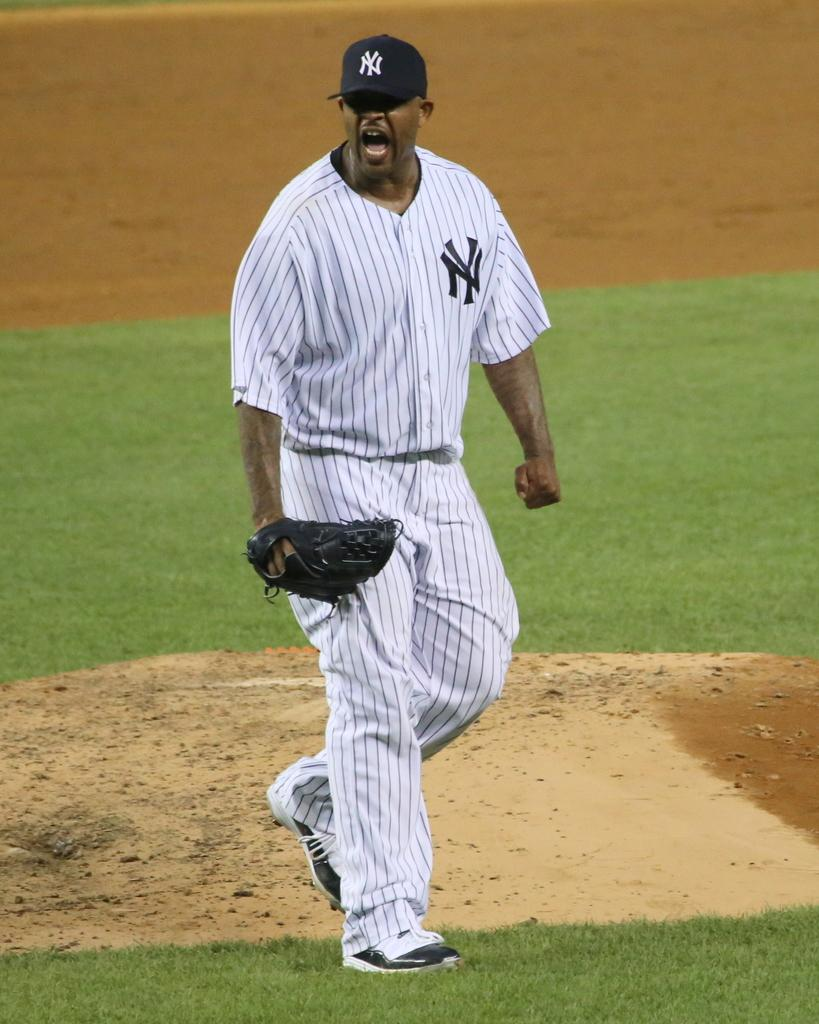Provide a one-sentence caption for the provided image. a baseball player yelling in a NY jersey and cap. 